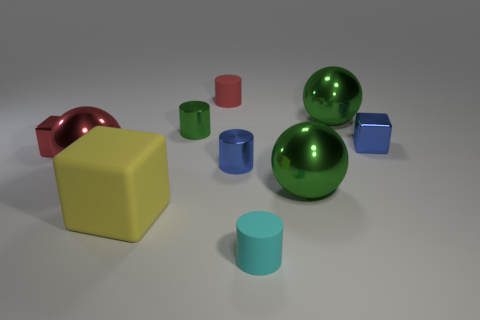Is the number of blue cylinders greater than the number of red matte spheres?
Your answer should be compact. Yes. Are there any small purple spheres?
Provide a short and direct response. No. How many objects are either rubber objects on the left side of the cyan rubber thing or small rubber cylinders in front of the large yellow rubber block?
Provide a succinct answer. 3. Is the number of tiny shiny cubes less than the number of big cubes?
Offer a terse response. No. There is a big yellow thing; are there any tiny blue shiny things in front of it?
Give a very brief answer. No. Are the large red thing and the tiny red cube made of the same material?
Provide a succinct answer. Yes. What color is the other matte object that is the same shape as the cyan thing?
Ensure brevity in your answer.  Red. What number of other tiny cylinders have the same material as the red cylinder?
Your answer should be very brief. 1. There is a yellow block; how many tiny cubes are on the left side of it?
Provide a succinct answer. 1. What size is the red cube?
Give a very brief answer. Small. 